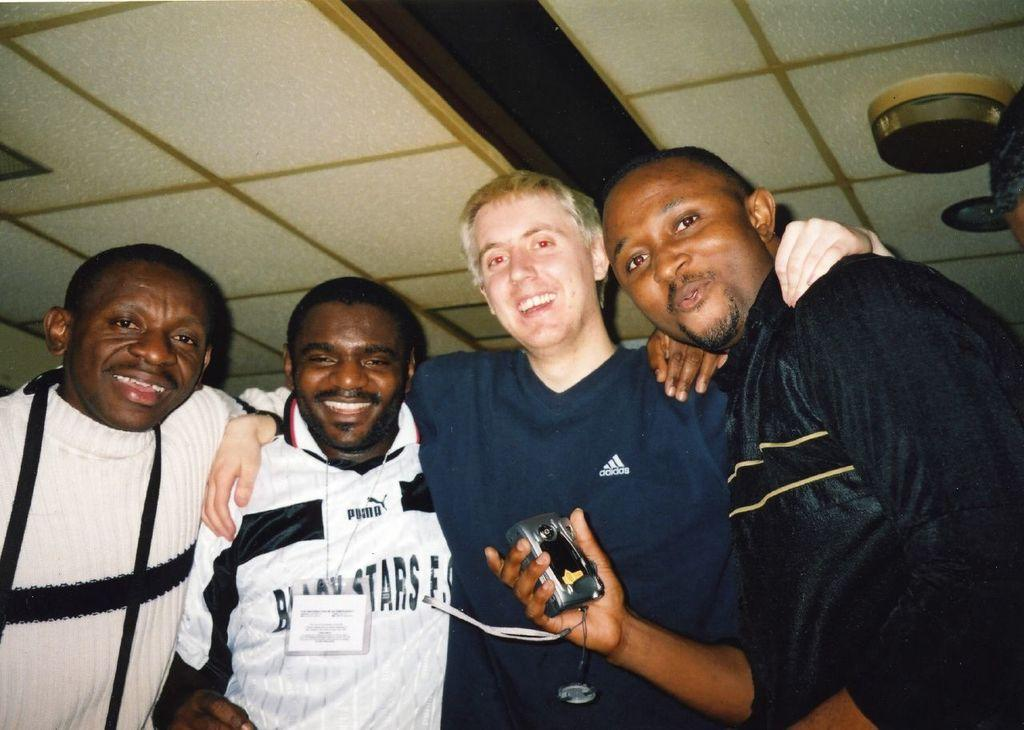Who is present in the image? There are people in the image. What is the facial expression of the people in the image? The people in the image are smiling. What is the man holding in his hand? The man is holding a camera in his hand. Can you describe the attire of one of the men in the image? One man is wearing an ID card. What type of treatment is the man with the camera receiving in the image? There is no indication in the image that the man with the camera is receiving any treatment. 